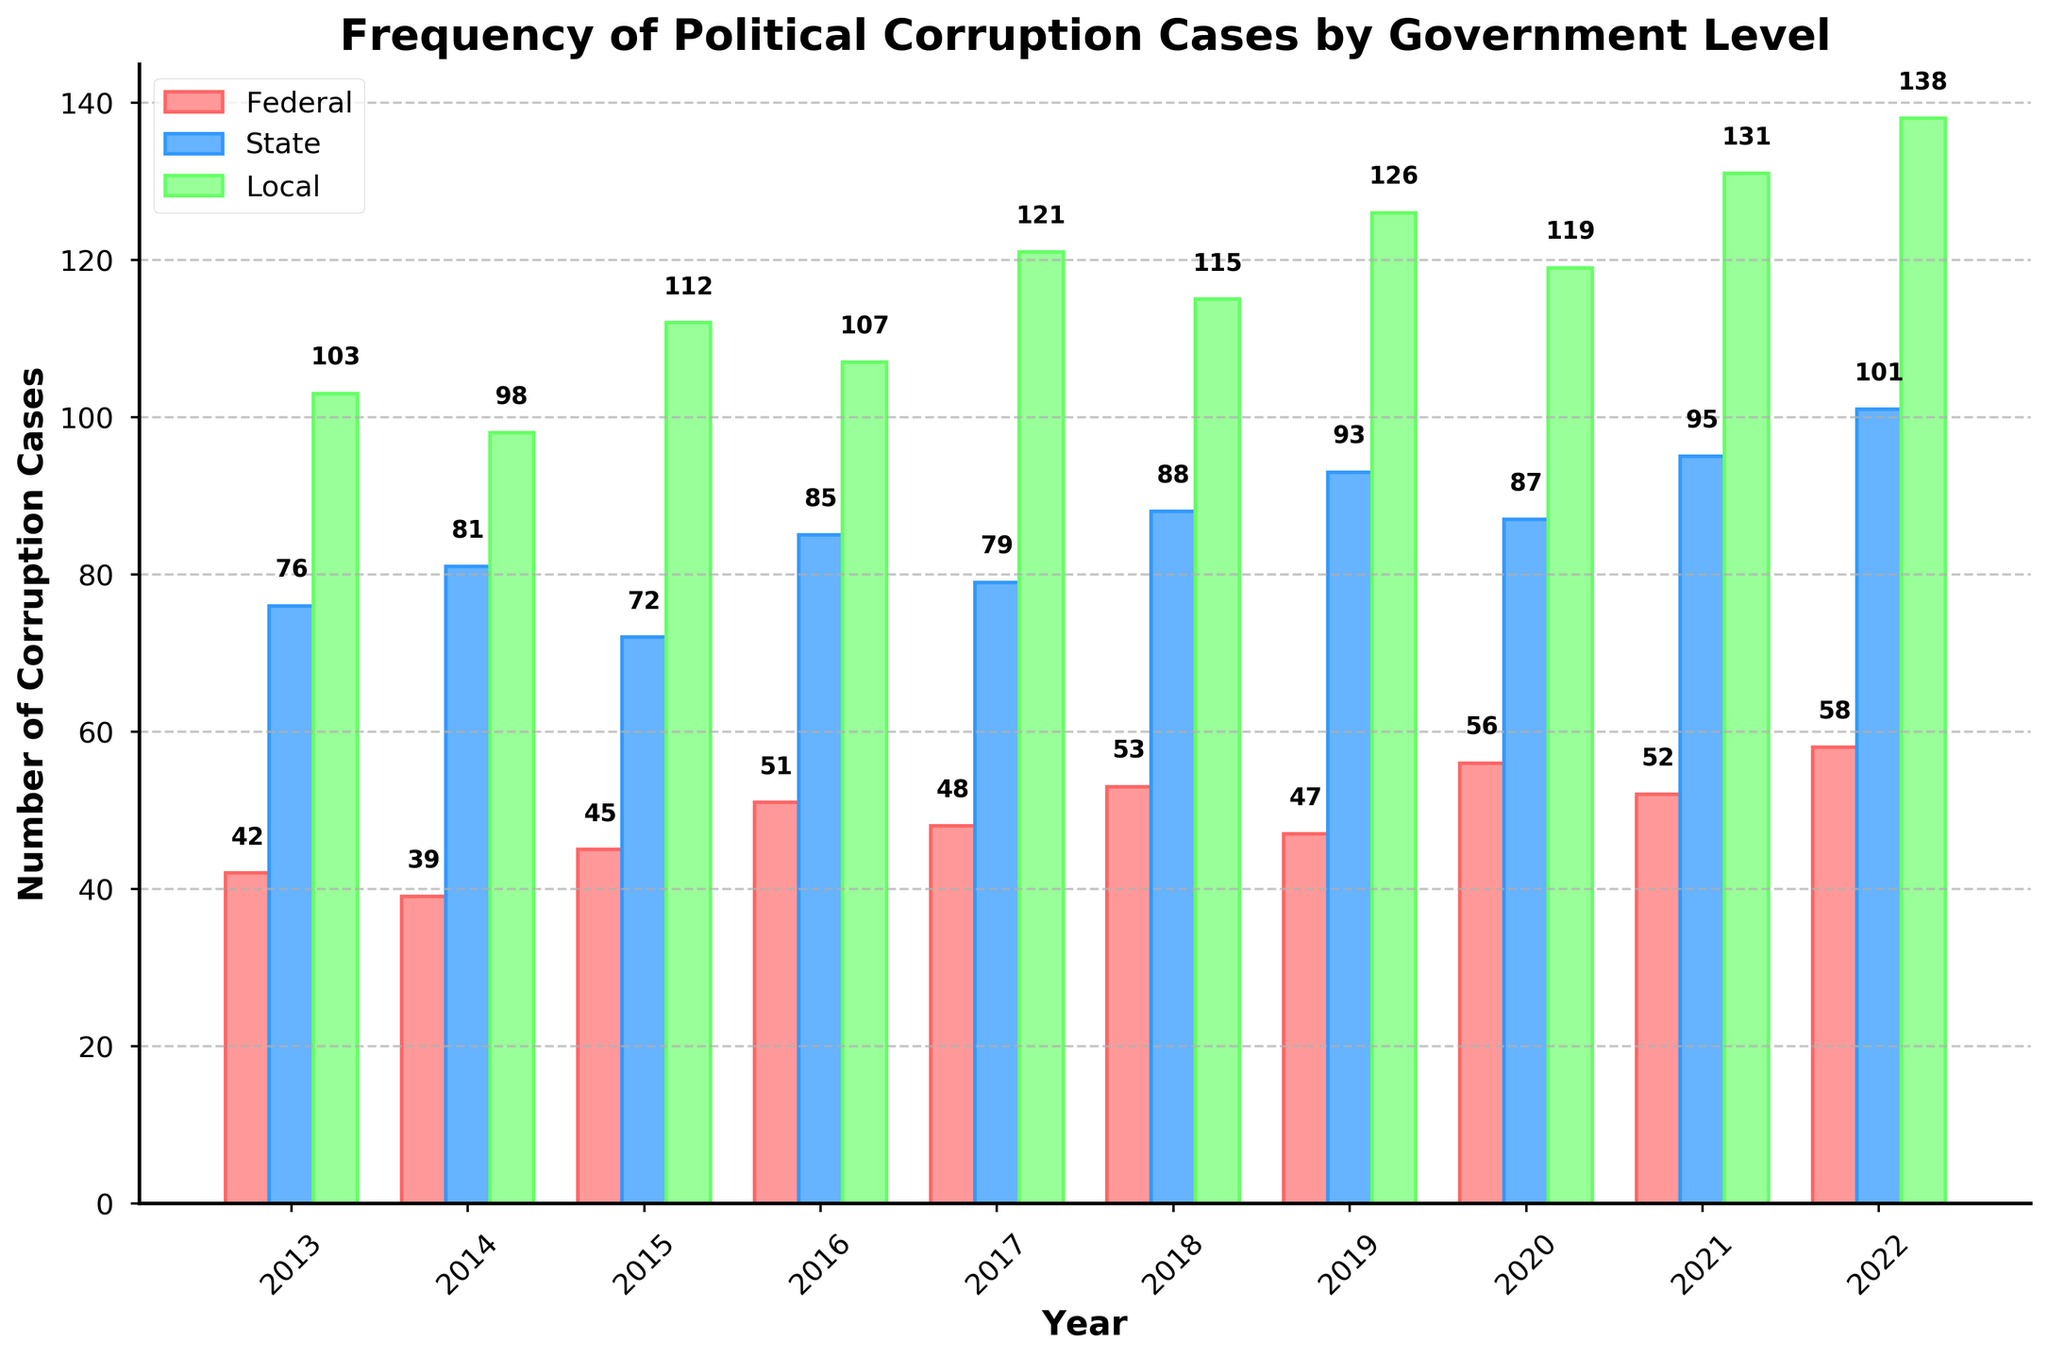What is the highest number of local corruption cases in any year? Look for the tallest green bar. In 2022, there are 138 local corruption cases.
Answer: 138 Which year had the lowest number of federal corruption cases? Identify the shortest red bar. The year 2014 has the lowest number of federal corruption cases with 39.
Answer: 2014 How many total corruption cases were there across all levels of government in 2022? Sum the values of the red, blue, and green bars for 2022: 58 (Federal) + 101 (State) + 138 (Local) = 297.
Answer: 297 In what year did state corruption cases surpass 90 for the first time? Look for the first instance where the blue bar exceeds 90. In 2019, state corruption cases were 93.
Answer: 2019 What is the difference between the number of federal and local corruption cases in 2017? Subtract the number of federal cases from local cases in 2017: 121 (Local) - 48 (Federal) = 73.
Answer: 73 Which government level consistently showed an increase in corruption cases from 2013 to 2022? Observe the trend of each colored bar. Local corruption cases (green) show an overall increasing trend.
Answer: Local During which years did federal corruption cases exceed 50? Identify the years when the red bar is above 50. Federal corruption cases exceeded 50 in 2016, 2020, and 2022.
Answer: 2016, 2020, 2022 By how much did state corruption cases change from 2018 to 2022? Subtract the number of state cases in 2018 from those in 2022: 101 (2022) - 88 (2018) = 13.
Answer: 13 